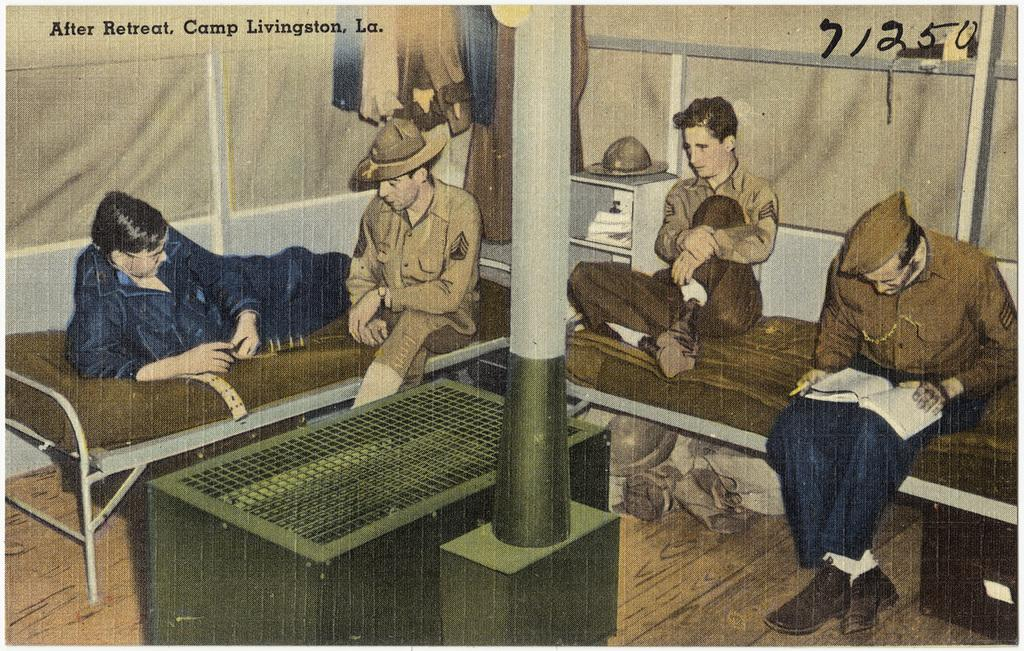What type of visual representation is the image? The image is a poster. What can be seen in the foreground of the poster? There is a pole in the poster. What is located behind the pole in the poster? There are beds behind the pole. What are the people on the beds doing? The people sitting on the beds are holding something. What is visible on the wall behind the beds? Clothes are present on the wall. What type of machine can be seen operating in the background of the poster? There is no machine present in the poster; it features a pole, beds, people, and a wall with clothes. Can you tell me how many animals are visible in the zoo depicted in the poster? There is no zoo depicted in the poster; it is a poster featuring a pole, beds, people, and a wall with clothes. 